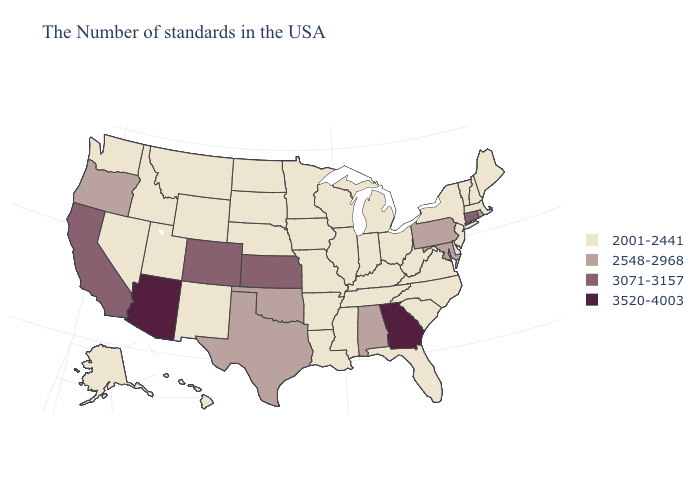What is the value of Ohio?
Concise answer only. 2001-2441. Name the states that have a value in the range 3520-4003?
Concise answer only. Georgia, Arizona. Does Pennsylvania have the lowest value in the Northeast?
Quick response, please. No. Is the legend a continuous bar?
Answer briefly. No. Among the states that border Montana , which have the lowest value?
Be succinct. South Dakota, North Dakota, Wyoming, Idaho. Does Arizona have the highest value in the USA?
Write a very short answer. Yes. Name the states that have a value in the range 3071-3157?
Be succinct. Connecticut, Kansas, Colorado, California. Name the states that have a value in the range 3071-3157?
Write a very short answer. Connecticut, Kansas, Colorado, California. What is the value of Kentucky?
Answer briefly. 2001-2441. What is the value of Alaska?
Write a very short answer. 2001-2441. Name the states that have a value in the range 3520-4003?
Short answer required. Georgia, Arizona. Which states have the lowest value in the Northeast?
Give a very brief answer. Maine, Massachusetts, New Hampshire, Vermont, New York, New Jersey. What is the highest value in states that border New Hampshire?
Be succinct. 2001-2441. Which states hav the highest value in the West?
Answer briefly. Arizona. 